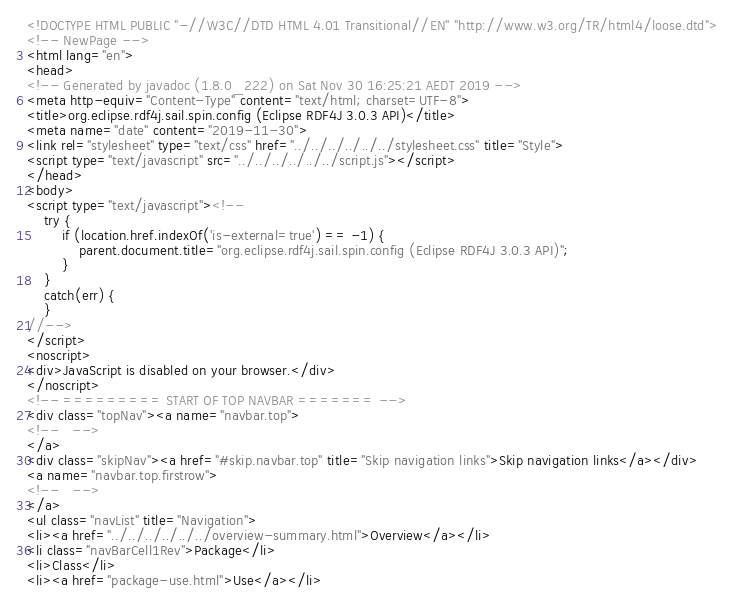Convert code to text. <code><loc_0><loc_0><loc_500><loc_500><_HTML_><!DOCTYPE HTML PUBLIC "-//W3C//DTD HTML 4.01 Transitional//EN" "http://www.w3.org/TR/html4/loose.dtd">
<!-- NewPage -->
<html lang="en">
<head>
<!-- Generated by javadoc (1.8.0_222) on Sat Nov 30 16:25:21 AEDT 2019 -->
<meta http-equiv="Content-Type" content="text/html; charset=UTF-8">
<title>org.eclipse.rdf4j.sail.spin.config (Eclipse RDF4J 3.0.3 API)</title>
<meta name="date" content="2019-11-30">
<link rel="stylesheet" type="text/css" href="../../../../../../stylesheet.css" title="Style">
<script type="text/javascript" src="../../../../../../script.js"></script>
</head>
<body>
<script type="text/javascript"><!--
    try {
        if (location.href.indexOf('is-external=true') == -1) {
            parent.document.title="org.eclipse.rdf4j.sail.spin.config (Eclipse RDF4J 3.0.3 API)";
        }
    }
    catch(err) {
    }
//-->
</script>
<noscript>
<div>JavaScript is disabled on your browser.</div>
</noscript>
<!-- ========= START OF TOP NAVBAR ======= -->
<div class="topNav"><a name="navbar.top">
<!--   -->
</a>
<div class="skipNav"><a href="#skip.navbar.top" title="Skip navigation links">Skip navigation links</a></div>
<a name="navbar.top.firstrow">
<!--   -->
</a>
<ul class="navList" title="Navigation">
<li><a href="../../../../../../overview-summary.html">Overview</a></li>
<li class="navBarCell1Rev">Package</li>
<li>Class</li>
<li><a href="package-use.html">Use</a></li></code> 